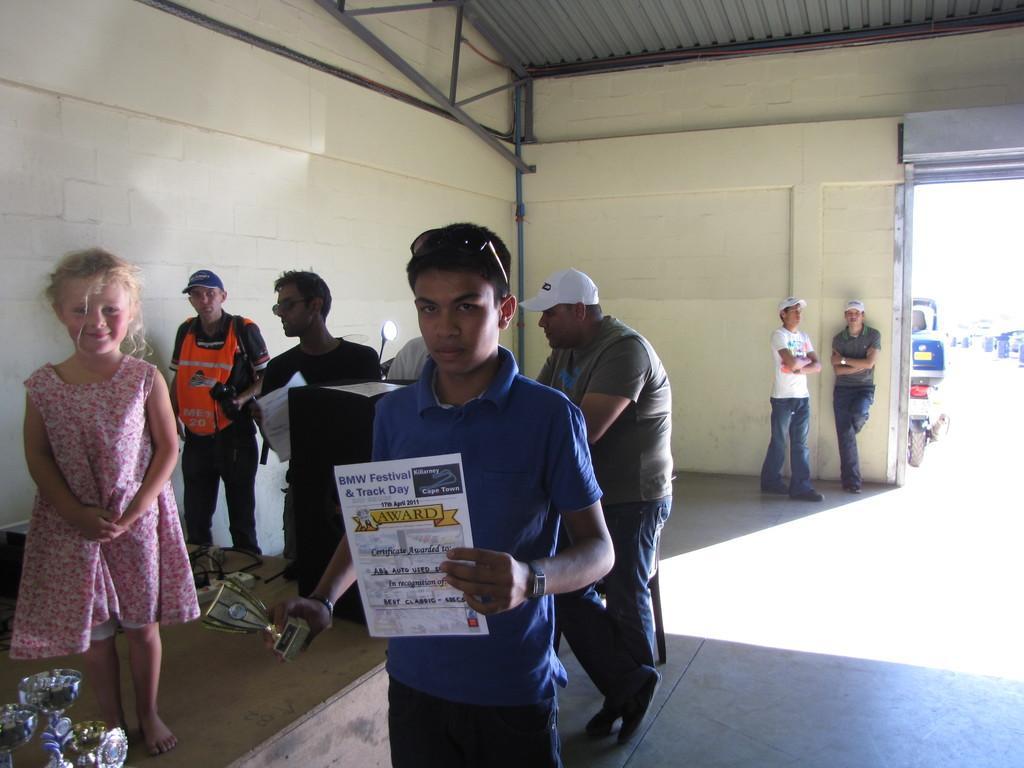Describe this image in one or two sentences. In the center of the image we can see a man is standing and holding a certificate, trophy and wearing dress, goggles. On the left side of the image we can see the stage. On the stage we can see a girl is standing and also we can see the glasses. Behind the stage we can see two people are standing. In the background of the image we can see the wall, rods, podium, door, shutter, some people. On the podium we can see the papers. Through door we can see the vehicles. At the bottom of the image we can see the floor. At the top of the image we can see the roof and rods. 